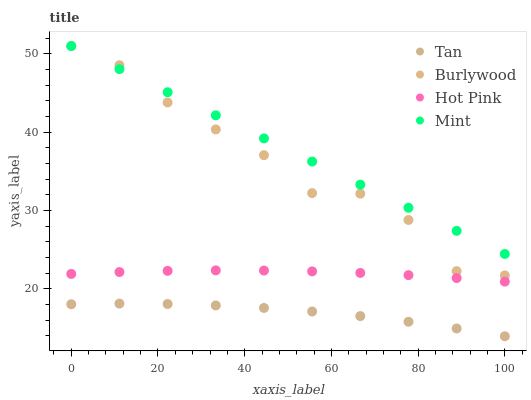Does Tan have the minimum area under the curve?
Answer yes or no. Yes. Does Mint have the maximum area under the curve?
Answer yes or no. Yes. Does Hot Pink have the minimum area under the curve?
Answer yes or no. No. Does Hot Pink have the maximum area under the curve?
Answer yes or no. No. Is Mint the smoothest?
Answer yes or no. Yes. Is Burlywood the roughest?
Answer yes or no. Yes. Is Tan the smoothest?
Answer yes or no. No. Is Tan the roughest?
Answer yes or no. No. Does Tan have the lowest value?
Answer yes or no. Yes. Does Hot Pink have the lowest value?
Answer yes or no. No. Does Mint have the highest value?
Answer yes or no. Yes. Does Hot Pink have the highest value?
Answer yes or no. No. Is Tan less than Burlywood?
Answer yes or no. Yes. Is Burlywood greater than Hot Pink?
Answer yes or no. Yes. Does Mint intersect Burlywood?
Answer yes or no. Yes. Is Mint less than Burlywood?
Answer yes or no. No. Is Mint greater than Burlywood?
Answer yes or no. No. Does Tan intersect Burlywood?
Answer yes or no. No. 